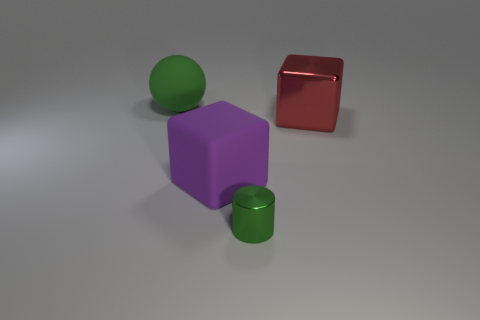Add 4 red objects. How many objects exist? 8 Subtract all cylinders. How many objects are left? 3 Add 3 tiny blue blocks. How many tiny blue blocks exist? 3 Subtract 0 red cylinders. How many objects are left? 4 Subtract all blocks. Subtract all large green things. How many objects are left? 1 Add 1 large green things. How many large green things are left? 2 